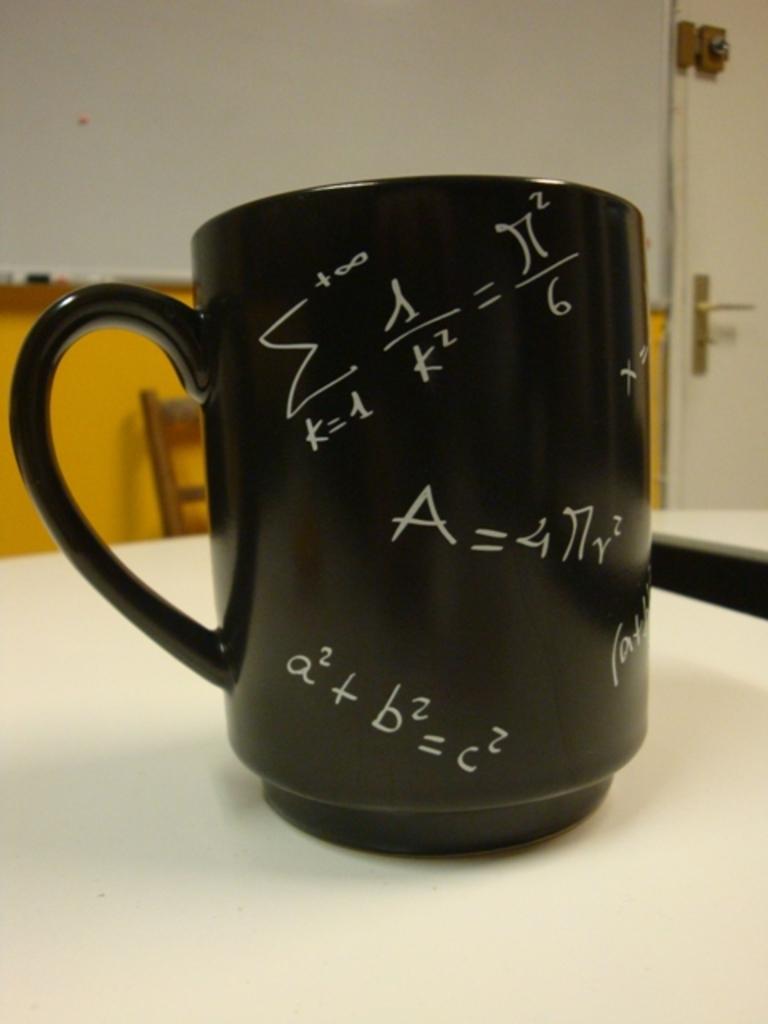What formulas are on the mug?
Provide a short and direct response. Unanswerable. 